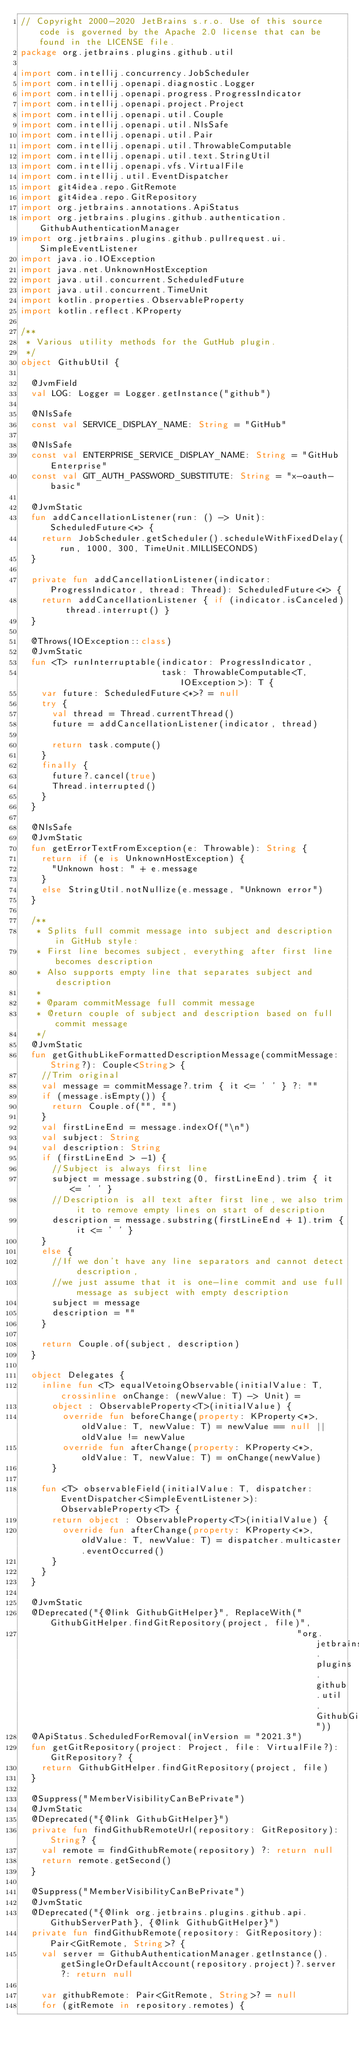Convert code to text. <code><loc_0><loc_0><loc_500><loc_500><_Kotlin_>// Copyright 2000-2020 JetBrains s.r.o. Use of this source code is governed by the Apache 2.0 license that can be found in the LICENSE file.
package org.jetbrains.plugins.github.util

import com.intellij.concurrency.JobScheduler
import com.intellij.openapi.diagnostic.Logger
import com.intellij.openapi.progress.ProgressIndicator
import com.intellij.openapi.project.Project
import com.intellij.openapi.util.Couple
import com.intellij.openapi.util.NlsSafe
import com.intellij.openapi.util.Pair
import com.intellij.openapi.util.ThrowableComputable
import com.intellij.openapi.util.text.StringUtil
import com.intellij.openapi.vfs.VirtualFile
import com.intellij.util.EventDispatcher
import git4idea.repo.GitRemote
import git4idea.repo.GitRepository
import org.jetbrains.annotations.ApiStatus
import org.jetbrains.plugins.github.authentication.GithubAuthenticationManager
import org.jetbrains.plugins.github.pullrequest.ui.SimpleEventListener
import java.io.IOException
import java.net.UnknownHostException
import java.util.concurrent.ScheduledFuture
import java.util.concurrent.TimeUnit
import kotlin.properties.ObservableProperty
import kotlin.reflect.KProperty

/**
 * Various utility methods for the GutHub plugin.
 */
object GithubUtil {

  @JvmField
  val LOG: Logger = Logger.getInstance("github")

  @NlsSafe
  const val SERVICE_DISPLAY_NAME: String = "GitHub"

  @NlsSafe
  const val ENTERPRISE_SERVICE_DISPLAY_NAME: String = "GitHub Enterprise"
  const val GIT_AUTH_PASSWORD_SUBSTITUTE: String = "x-oauth-basic"

  @JvmStatic
  fun addCancellationListener(run: () -> Unit): ScheduledFuture<*> {
    return JobScheduler.getScheduler().scheduleWithFixedDelay(run, 1000, 300, TimeUnit.MILLISECONDS)
  }

  private fun addCancellationListener(indicator: ProgressIndicator, thread: Thread): ScheduledFuture<*> {
    return addCancellationListener { if (indicator.isCanceled) thread.interrupt() }
  }

  @Throws(IOException::class)
  @JvmStatic
  fun <T> runInterruptable(indicator: ProgressIndicator,
                           task: ThrowableComputable<T, IOException>): T {
    var future: ScheduledFuture<*>? = null
    try {
      val thread = Thread.currentThread()
      future = addCancellationListener(indicator, thread)

      return task.compute()
    }
    finally {
      future?.cancel(true)
      Thread.interrupted()
    }
  }

  @NlsSafe
  @JvmStatic
  fun getErrorTextFromException(e: Throwable): String {
    return if (e is UnknownHostException) {
      "Unknown host: " + e.message
    }
    else StringUtil.notNullize(e.message, "Unknown error")
  }

  /**
   * Splits full commit message into subject and description in GitHub style:
   * First line becomes subject, everything after first line becomes description
   * Also supports empty line that separates subject and description
   *
   * @param commitMessage full commit message
   * @return couple of subject and description based on full commit message
   */
  @JvmStatic
  fun getGithubLikeFormattedDescriptionMessage(commitMessage: String?): Couple<String> {
    //Trim original
    val message = commitMessage?.trim { it <= ' ' } ?: ""
    if (message.isEmpty()) {
      return Couple.of("", "")
    }
    val firstLineEnd = message.indexOf("\n")
    val subject: String
    val description: String
    if (firstLineEnd > -1) {
      //Subject is always first line
      subject = message.substring(0, firstLineEnd).trim { it <= ' ' }
      //Description is all text after first line, we also trim it to remove empty lines on start of description
      description = message.substring(firstLineEnd + 1).trim { it <= ' ' }
    }
    else {
      //If we don't have any line separators and cannot detect description,
      //we just assume that it is one-line commit and use full message as subject with empty description
      subject = message
      description = ""
    }

    return Couple.of(subject, description)
  }

  object Delegates {
    inline fun <T> equalVetoingObservable(initialValue: T, crossinline onChange: (newValue: T) -> Unit) =
      object : ObservableProperty<T>(initialValue) {
        override fun beforeChange(property: KProperty<*>, oldValue: T, newValue: T) = newValue == null || oldValue != newValue
        override fun afterChange(property: KProperty<*>, oldValue: T, newValue: T) = onChange(newValue)
      }

    fun <T> observableField(initialValue: T, dispatcher: EventDispatcher<SimpleEventListener>): ObservableProperty<T> {
      return object : ObservableProperty<T>(initialValue) {
        override fun afterChange(property: KProperty<*>, oldValue: T, newValue: T) = dispatcher.multicaster.eventOccurred()
      }
    }
  }

  @JvmStatic
  @Deprecated("{@link GithubGitHelper}", ReplaceWith("GithubGitHelper.findGitRepository(project, file)",
                                                     "org.jetbrains.plugins.github.util.GithubGitHelper"))
  @ApiStatus.ScheduledForRemoval(inVersion = "2021.3")
  fun getGitRepository(project: Project, file: VirtualFile?): GitRepository? {
    return GithubGitHelper.findGitRepository(project, file)
  }

  @Suppress("MemberVisibilityCanBePrivate")
  @JvmStatic
  @Deprecated("{@link GithubGitHelper}")
  private fun findGithubRemoteUrl(repository: GitRepository): String? {
    val remote = findGithubRemote(repository) ?: return null
    return remote.getSecond()
  }

  @Suppress("MemberVisibilityCanBePrivate")
  @JvmStatic
  @Deprecated("{@link org.jetbrains.plugins.github.api.GithubServerPath}, {@link GithubGitHelper}")
  private fun findGithubRemote(repository: GitRepository): Pair<GitRemote, String>? {
    val server = GithubAuthenticationManager.getInstance().getSingleOrDefaultAccount(repository.project)?.server ?: return null

    var githubRemote: Pair<GitRemote, String>? = null
    for (gitRemote in repository.remotes) {</code> 